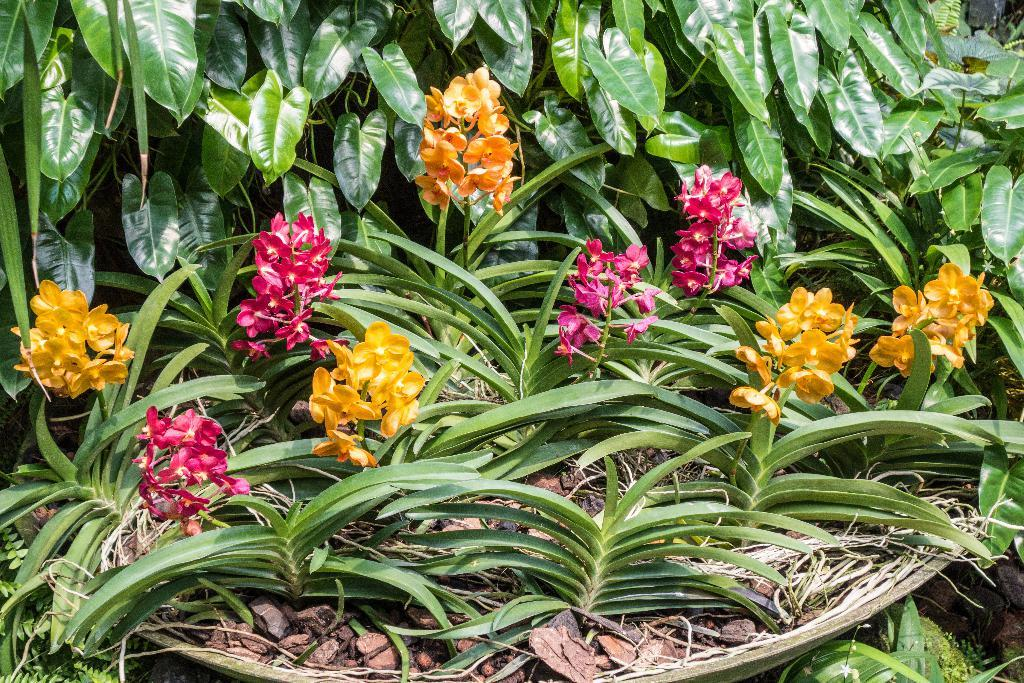What object is present in the image that can hold items? There is a basket in the image. What is inside the basket? The basket contains yellow and pink flower plants. Are there any other visible elements related to the plants in the image? Yes, there are leaves visible in the image. What type of silver picture frame is present in the image? There is no silver picture frame present in the image. What shape is the basket in the image? The shape of the basket cannot be determined from the image alone, as it is not visible in its entirety. 